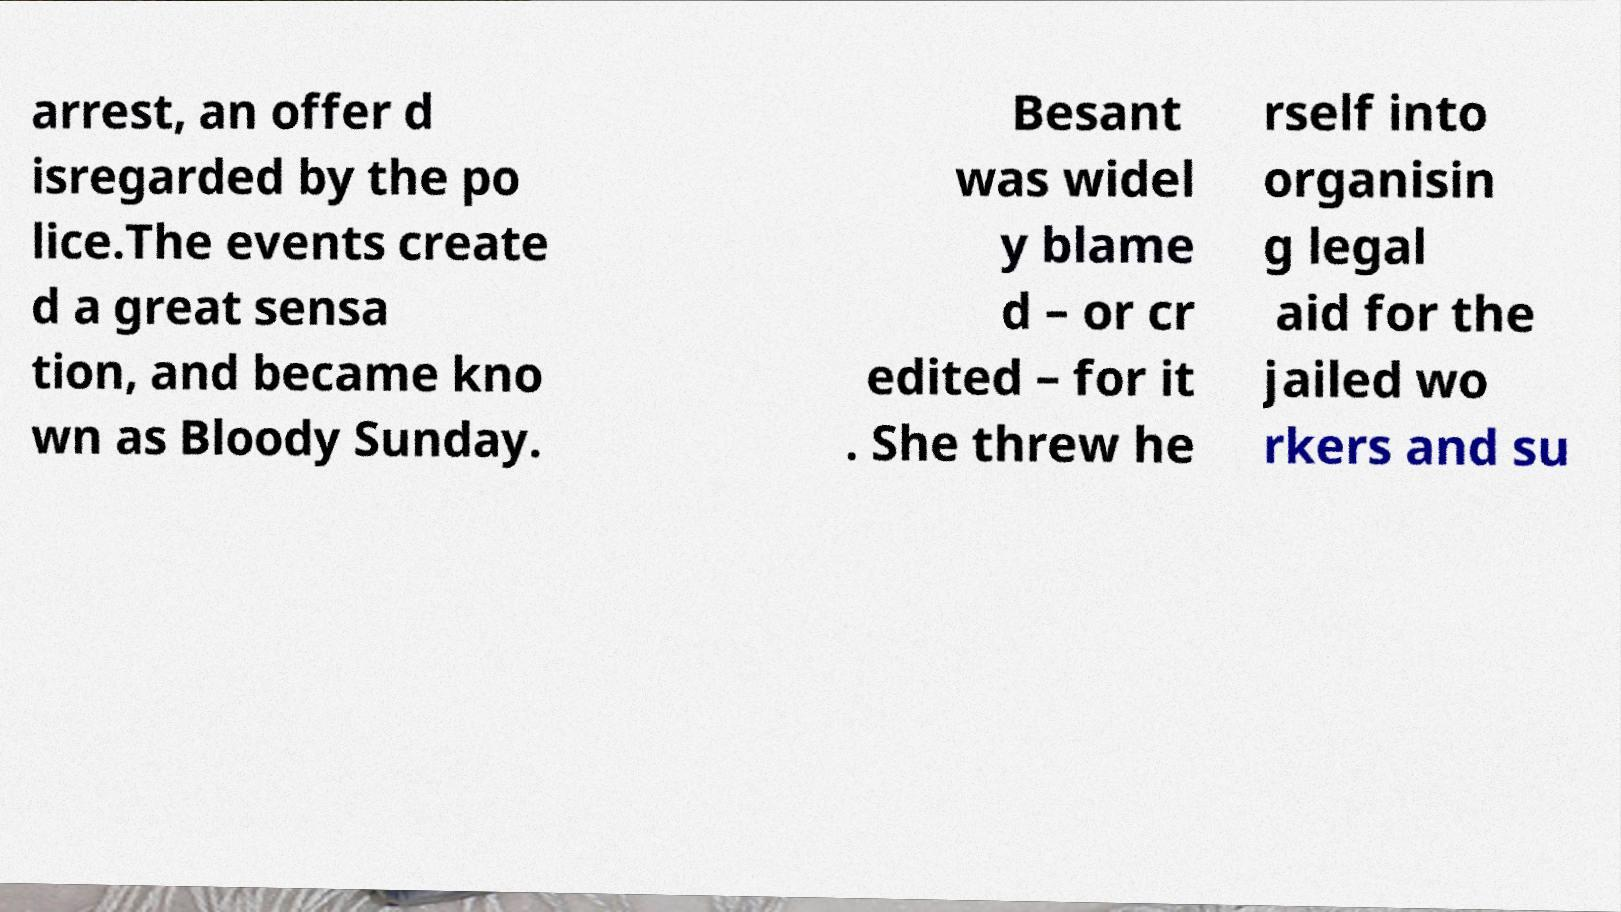There's text embedded in this image that I need extracted. Can you transcribe it verbatim? arrest, an offer d isregarded by the po lice.The events create d a great sensa tion, and became kno wn as Bloody Sunday. Besant was widel y blame d – or cr edited – for it . She threw he rself into organisin g legal aid for the jailed wo rkers and su 